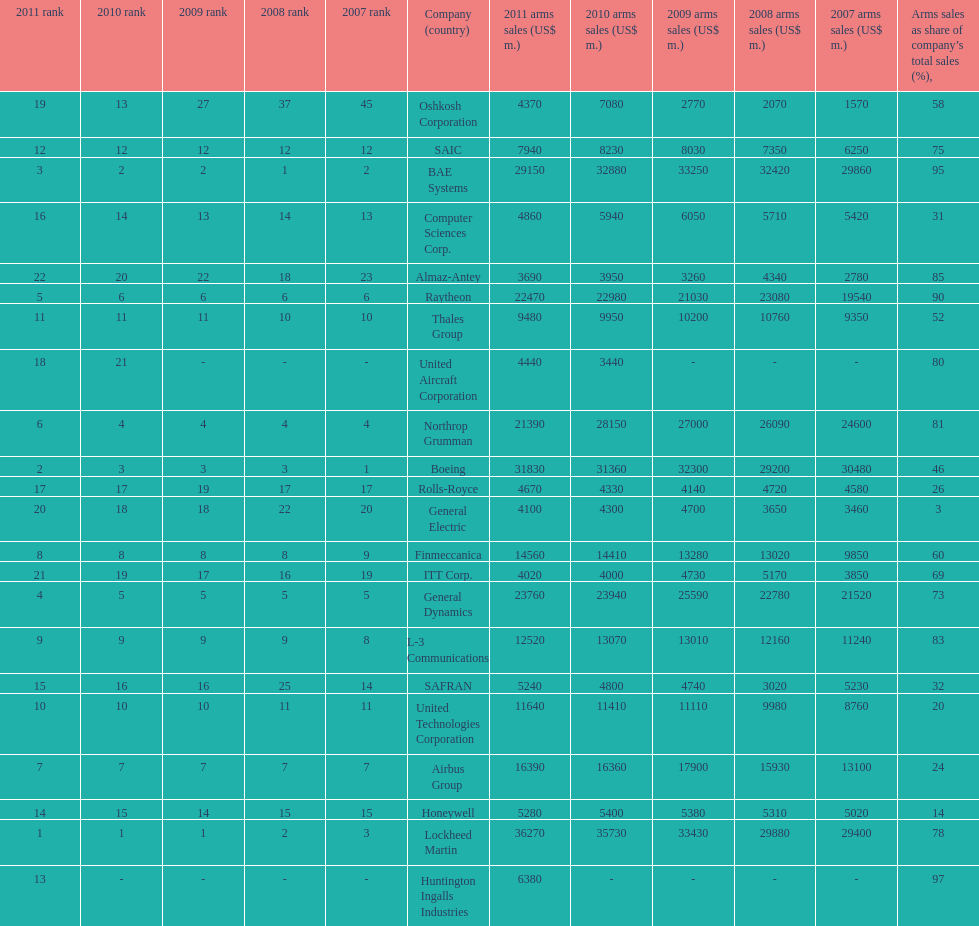Which company had the highest 2009 arms sales? Lockheed Martin. 